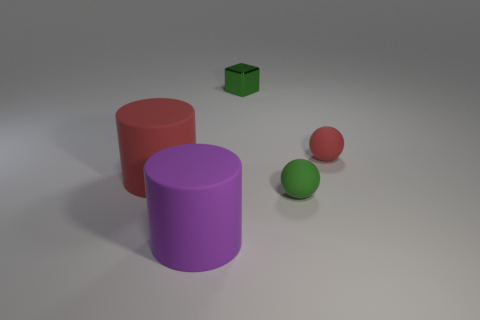What is the material of the small green thing that is behind the cylinder to the left of the big purple cylinder?
Offer a very short reply. Metal. What shape is the object that is both in front of the red matte sphere and right of the purple thing?
Your response must be concise. Sphere. What is the size of the green thing that is the same shape as the small red matte object?
Provide a succinct answer. Small. Are there fewer large objects behind the small green metal cube than tiny purple metal cubes?
Your response must be concise. No. How big is the red thing to the left of the tiny green ball?
Ensure brevity in your answer.  Large. The other large thing that is the same shape as the purple object is what color?
Keep it short and to the point. Red. What number of other things are the same color as the small shiny object?
Provide a short and direct response. 1. Is there anything else that has the same shape as the small green metallic object?
Offer a very short reply. No. Is there a rubber cylinder that is in front of the big rubber cylinder behind the small green thing that is in front of the small metal object?
Your answer should be compact. Yes. What number of red things have the same material as the small green cube?
Make the answer very short. 0. 